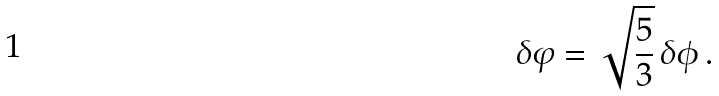Convert formula to latex. <formula><loc_0><loc_0><loc_500><loc_500>\delta \varphi = \sqrt { \frac { 5 } { 3 } } \, \delta \phi \, .</formula> 